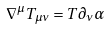<formula> <loc_0><loc_0><loc_500><loc_500>\nabla ^ { \mu } T _ { \mu \nu } = T \partial _ { \nu } \alpha</formula> 